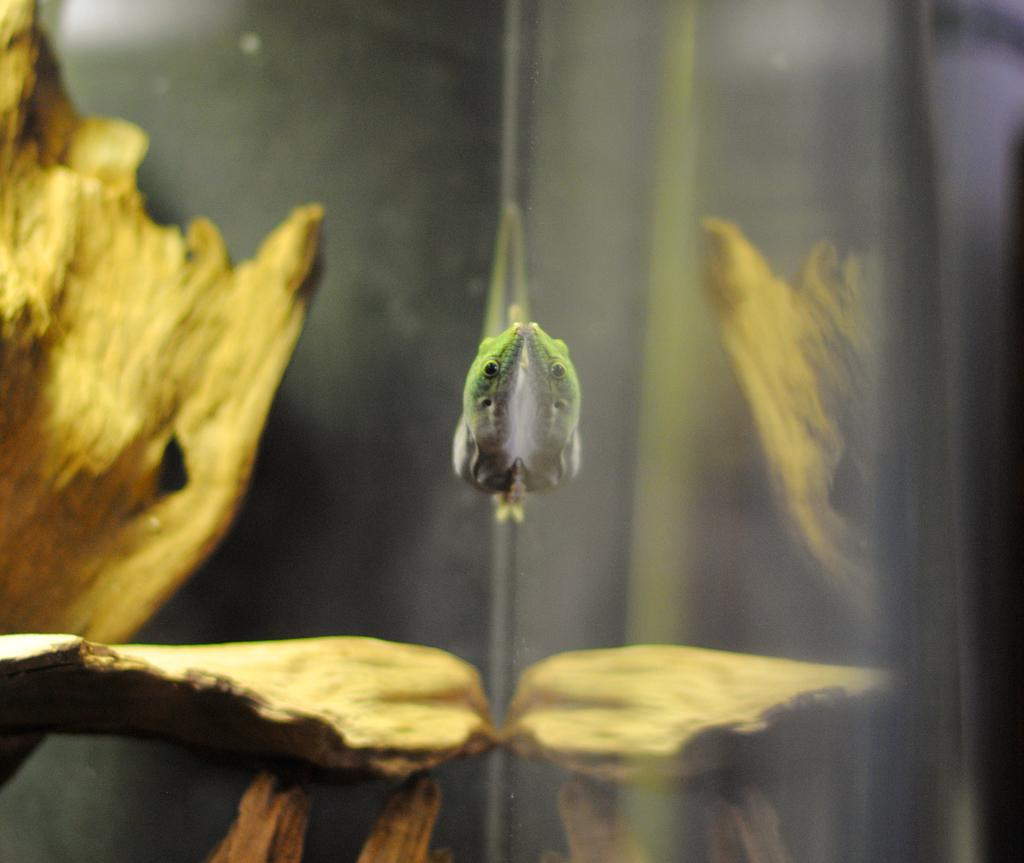What type of animal is on the surface in the image? The specific type of animal cannot be determined from the provided facts. What can be seen in the background of the image? There are wood pieces visible in the background of the image. What does the caption say about the pollution in the image? There is no caption present in the image, and therefore no information about pollution can be derived from it. 